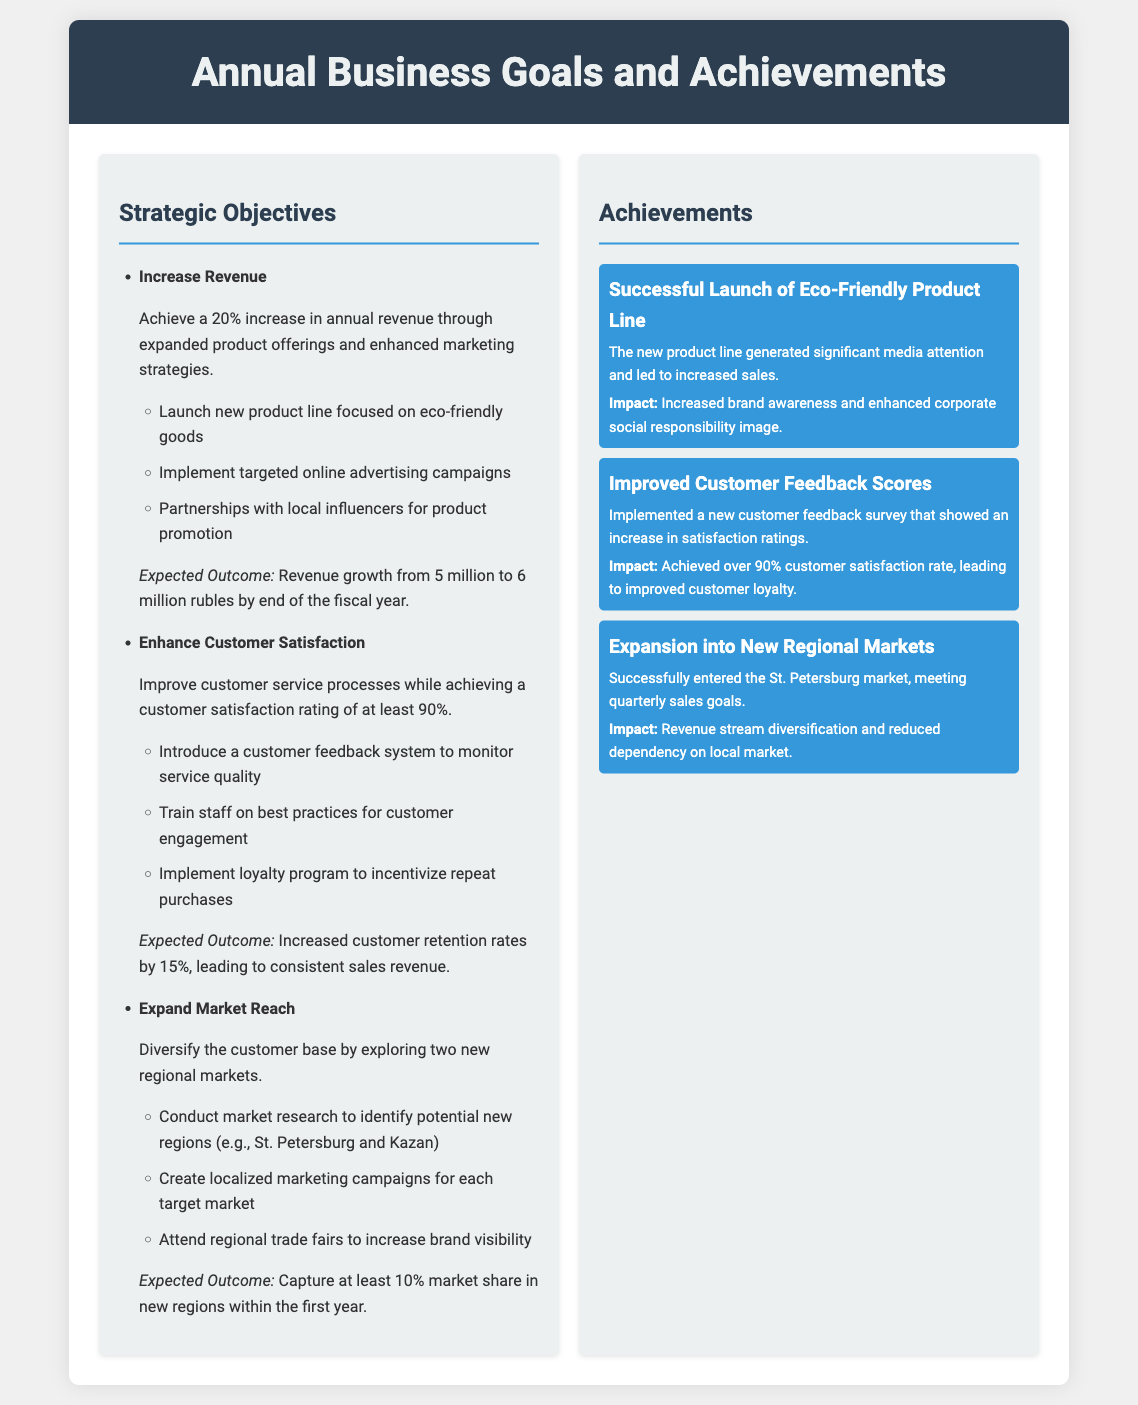What is the target revenue increase percentage? The document states the goal is to achieve a 20% increase in annual revenue.
Answer: 20% What is the expected revenue growth in rubles? The expected outcome reflects revenue growth from 5 million to 6 million rubles.
Answer: 6 million rubles What customer satisfaction rating goal is mentioned? The goal for customer satisfaction is to achieve a rating of at least 90%.
Answer: 90% Which cities are targeted for market expansion? The document mentions exploring two new regional markets: St. Petersburg and Kazan.
Answer: St. Petersburg and Kazan What impact did the eco-friendly product line launch have? The launch generated significant media attention and led to increased sales.
Answer: Increased sales What is the impact of improved customer feedback scores? Achieving over 90% customer satisfaction rate led to improved customer loyalty.
Answer: Improved customer loyalty How many new regional markets does the business plan to explore? The business plans to diversify by exploring two new regional markets.
Answer: Two What strategy is used to enhance customer satisfaction? The document mentions implementing a customer feedback system to monitor service quality.
Answer: Customer feedback system What was achieved in the St. Petersburg market? The business successfully met quarterly sales goals in the St. Petersburg market.
Answer: Quarterly sales goals 